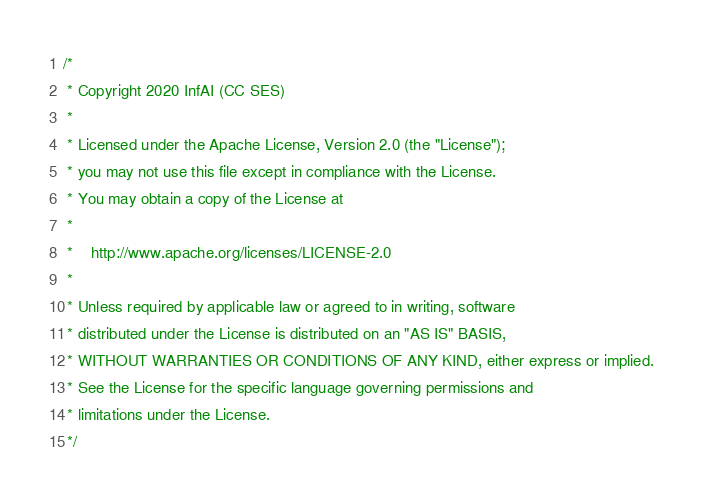Convert code to text. <code><loc_0><loc_0><loc_500><loc_500><_Go_>/*
 * Copyright 2020 InfAI (CC SES)
 *
 * Licensed under the Apache License, Version 2.0 (the "License");
 * you may not use this file except in compliance with the License.
 * You may obtain a copy of the License at
 *
 *    http://www.apache.org/licenses/LICENSE-2.0
 *
 * Unless required by applicable law or agreed to in writing, software
 * distributed under the License is distributed on an "AS IS" BASIS,
 * WITHOUT WARRANTIES OR CONDITIONS OF ANY KIND, either express or implied.
 * See the License for the specific language governing permissions and
 * limitations under the License.
 */
</code> 